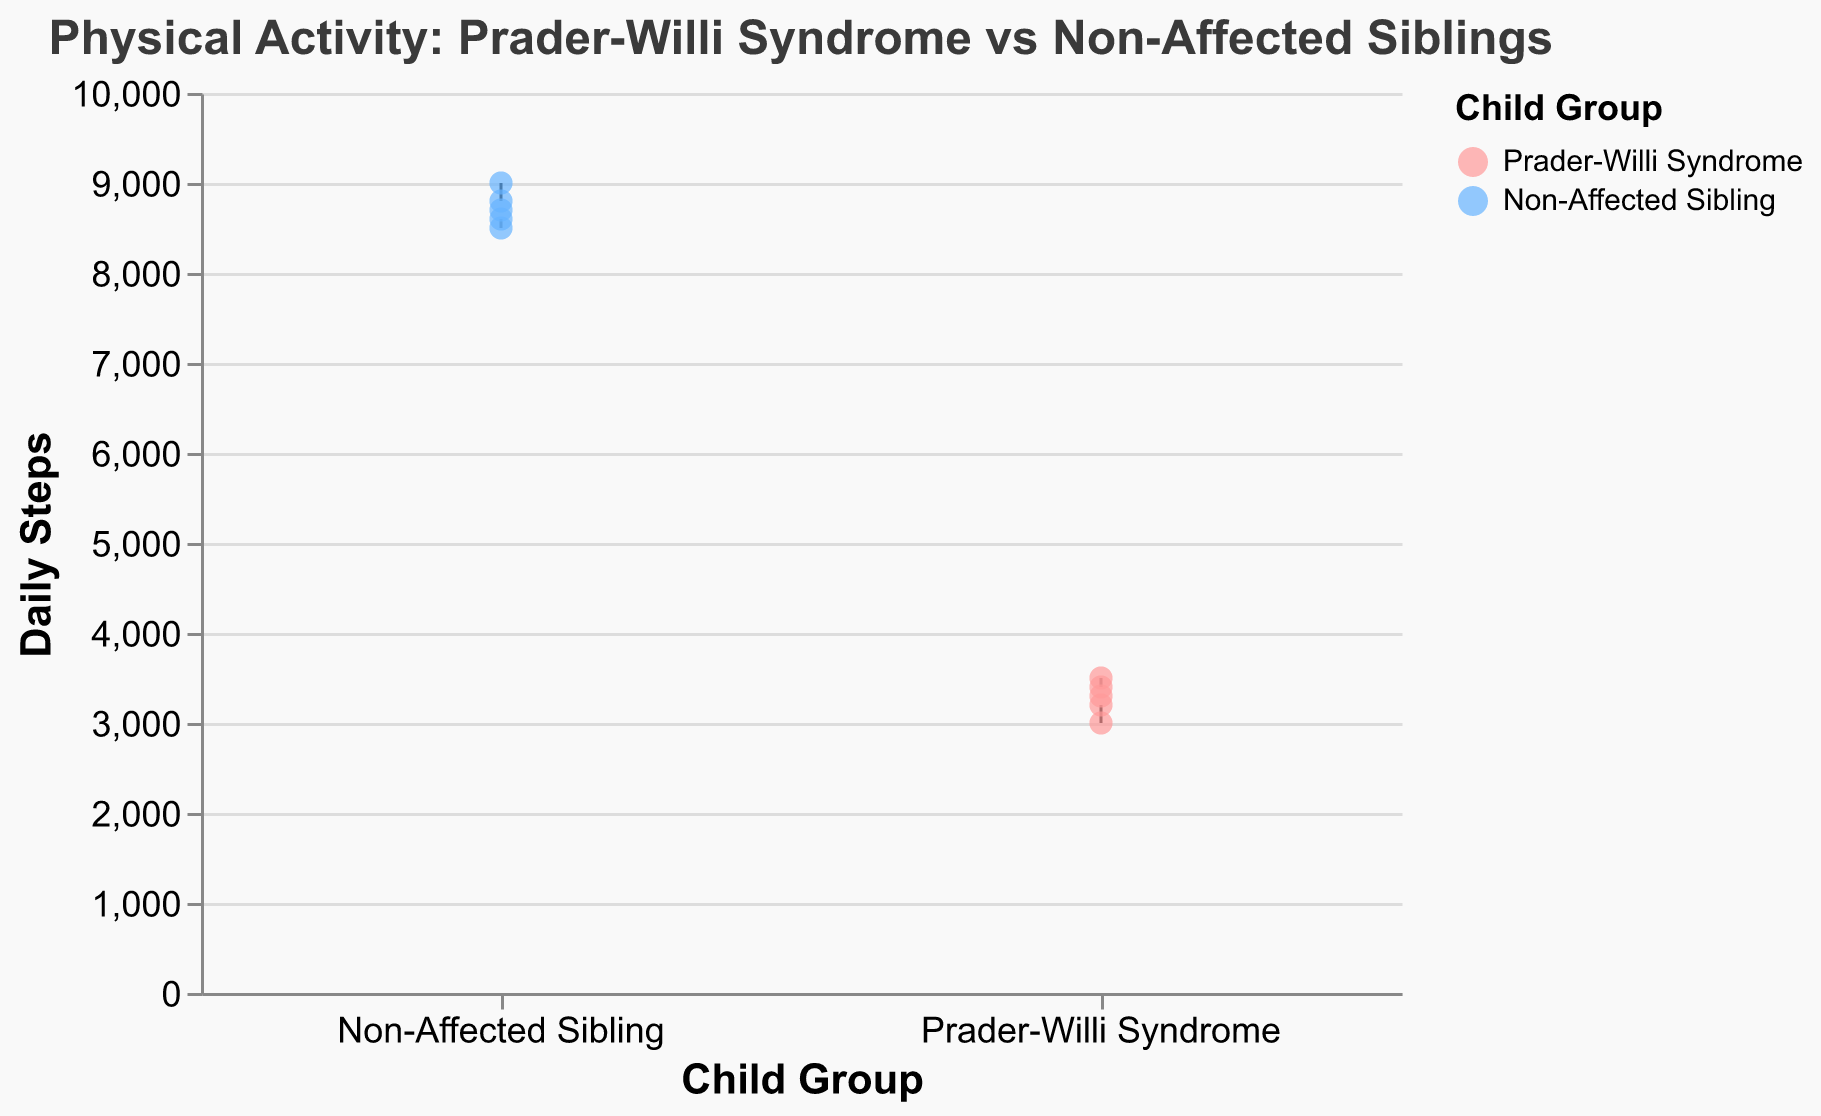What are the two groups compared in the figure? The figure title and the x-axis indicate that the comparison is between children with Prader-Willi Syndrome and their non-affected siblings.
Answer: Prader-Willi Syndrome and Non-Affected Siblings What is the title of the figure? The title is displayed at the top of the figure and clearly states the main topic of comparison.
Answer: Physical Activity: Prader-Willi Syndrome vs Non-Affected Siblings Which group, on average, has higher daily steps? Observing the median lines inside the box plots for the two groups, the non-affected siblings have higher median daily steps compared to the children with Prader-Willi Syndrome.
Answer: Non-Affected Siblings What is the median daily steps for children with Prader-Willi Syndrome? The median is indicated by the line inside the box plot for the Prader-Willi Syndrome group, falling around 3300 steps.
Answer: 3300 steps What is the range of daily steps for non-affected siblings? The minimum and maximum values of the box plot for non-affected siblings range from approximately 8500 to 9000 steps.
Answer: 8500 to 9000 steps Which group exhibited a wider range of daily steps? Comparing the length of the box plots, the Prader-Willi Syndrome group shows a wider range of daily steps from around 3000 to 3500, while Non-Affected Siblings have a range from 8500 to 9000.
Answer: Prader-Willi Syndrome How many children are in each group? The width of the boxes represents the count of children in each group. Both groups have boxes of equal width, each representing 5 children.
Answer: 5 children What is the color scheme used to differentiate between the groups? The non-affected siblings are colored in a shade of blue, and the children with Prader-Willi Syndrome are colored in a shade of pink.
Answer: Blue and Pink Based on the data, what conclusion can be made about the average physical activity levels between the two groups? Comparing the median daily steps and range, it is evident that non-affected siblings have significantly higher daily steps and a narrower range, indicating more consistent higher activity levels compared to children with Prader-Willi Syndrome.
Answer: Non-Affected Siblings are more active on average 